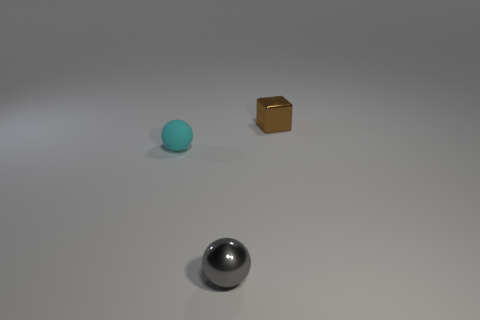Add 3 gray balls. How many objects exist? 6 Subtract all balls. How many objects are left? 1 Add 1 tiny cyan spheres. How many tiny cyan spheres exist? 2 Subtract 0 gray blocks. How many objects are left? 3 Subtract all big gray shiny cylinders. Subtract all brown objects. How many objects are left? 2 Add 1 small matte objects. How many small matte objects are left? 2 